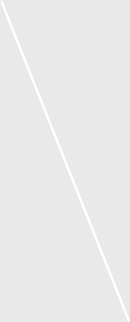Convert chart to OTSL. <chart><loc_0><loc_0><loc_500><loc_500><pie_chart><fcel>Balances at December 31 2005<nl><fcel>100.0%<nl></chart> 